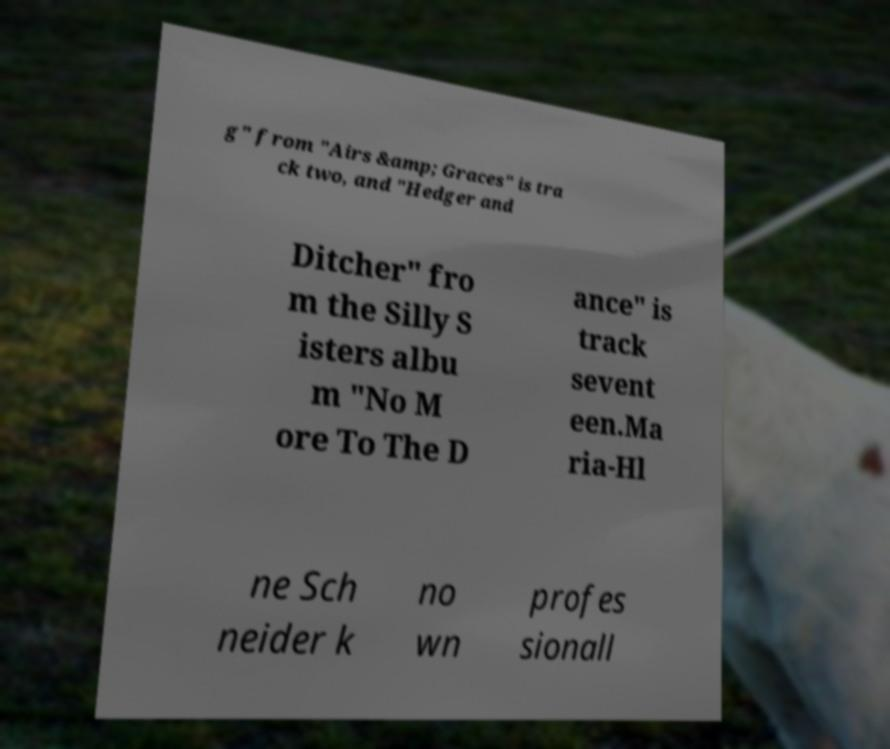For documentation purposes, I need the text within this image transcribed. Could you provide that? g" from "Airs &amp; Graces" is tra ck two, and "Hedger and Ditcher" fro m the Silly S isters albu m "No M ore To The D ance" is track sevent een.Ma ria-Hl ne Sch neider k no wn profes sionall 